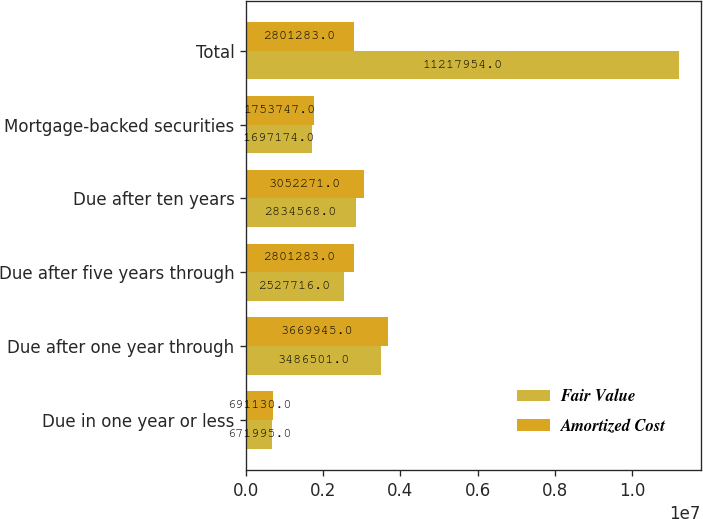Convert chart to OTSL. <chart><loc_0><loc_0><loc_500><loc_500><stacked_bar_chart><ecel><fcel>Due in one year or less<fcel>Due after one year through<fcel>Due after five years through<fcel>Due after ten years<fcel>Mortgage-backed securities<fcel>Total<nl><fcel>Fair Value<fcel>671995<fcel>3.4865e+06<fcel>2.52772e+06<fcel>2.83457e+06<fcel>1.69717e+06<fcel>1.1218e+07<nl><fcel>Amortized Cost<fcel>691130<fcel>3.66994e+06<fcel>2.80128e+06<fcel>3.05227e+06<fcel>1.75375e+06<fcel>2.80128e+06<nl></chart> 